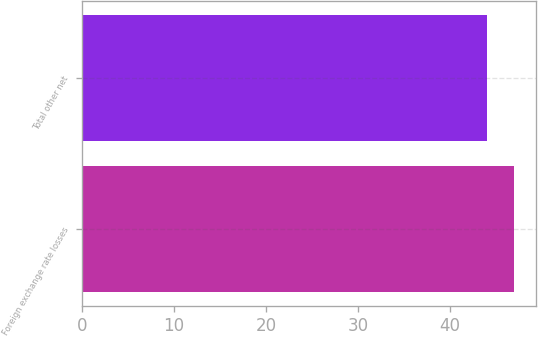<chart> <loc_0><loc_0><loc_500><loc_500><bar_chart><fcel>Foreign exchange rate losses<fcel>Total other net<nl><fcel>47<fcel>44<nl></chart> 